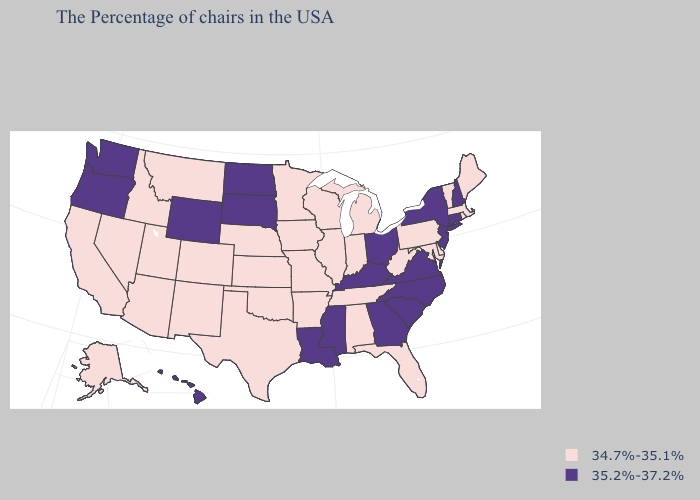Does Montana have the highest value in the USA?
Write a very short answer. No. What is the lowest value in the USA?
Keep it brief. 34.7%-35.1%. What is the value of Alabama?
Keep it brief. 34.7%-35.1%. Does Ohio have the highest value in the MidWest?
Short answer required. Yes. What is the value of Ohio?
Keep it brief. 35.2%-37.2%. Among the states that border South Dakota , which have the lowest value?
Short answer required. Minnesota, Iowa, Nebraska, Montana. How many symbols are there in the legend?
Quick response, please. 2. Does Kansas have the highest value in the USA?
Be succinct. No. What is the highest value in the Northeast ?
Quick response, please. 35.2%-37.2%. Name the states that have a value in the range 34.7%-35.1%?
Quick response, please. Maine, Massachusetts, Rhode Island, Vermont, Delaware, Maryland, Pennsylvania, West Virginia, Florida, Michigan, Indiana, Alabama, Tennessee, Wisconsin, Illinois, Missouri, Arkansas, Minnesota, Iowa, Kansas, Nebraska, Oklahoma, Texas, Colorado, New Mexico, Utah, Montana, Arizona, Idaho, Nevada, California, Alaska. Does the map have missing data?
Keep it brief. No. Name the states that have a value in the range 35.2%-37.2%?
Quick response, please. New Hampshire, Connecticut, New York, New Jersey, Virginia, North Carolina, South Carolina, Ohio, Georgia, Kentucky, Mississippi, Louisiana, South Dakota, North Dakota, Wyoming, Washington, Oregon, Hawaii. Is the legend a continuous bar?
Concise answer only. No. Name the states that have a value in the range 34.7%-35.1%?
Write a very short answer. Maine, Massachusetts, Rhode Island, Vermont, Delaware, Maryland, Pennsylvania, West Virginia, Florida, Michigan, Indiana, Alabama, Tennessee, Wisconsin, Illinois, Missouri, Arkansas, Minnesota, Iowa, Kansas, Nebraska, Oklahoma, Texas, Colorado, New Mexico, Utah, Montana, Arizona, Idaho, Nevada, California, Alaska. Does the map have missing data?
Keep it brief. No. 